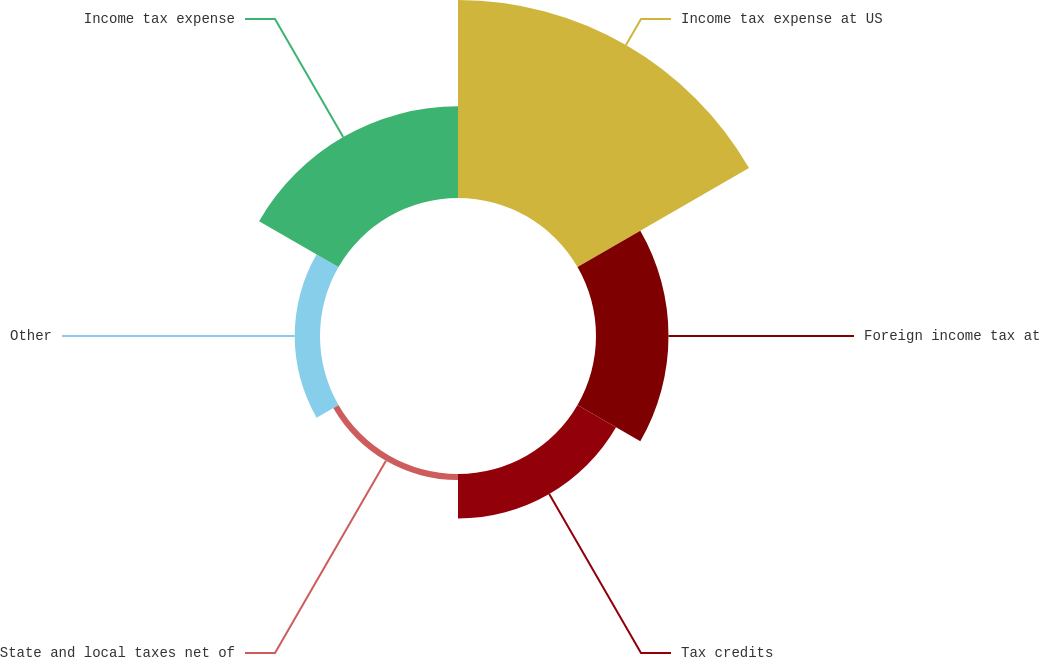Convert chart to OTSL. <chart><loc_0><loc_0><loc_500><loc_500><pie_chart><fcel>Income tax expense at US<fcel>Foreign income tax at<fcel>Tax credits<fcel>State and local taxes net of<fcel>Other<fcel>Income tax expense<nl><fcel>45.2%<fcel>16.55%<fcel>10.15%<fcel>1.39%<fcel>5.77%<fcel>20.93%<nl></chart> 